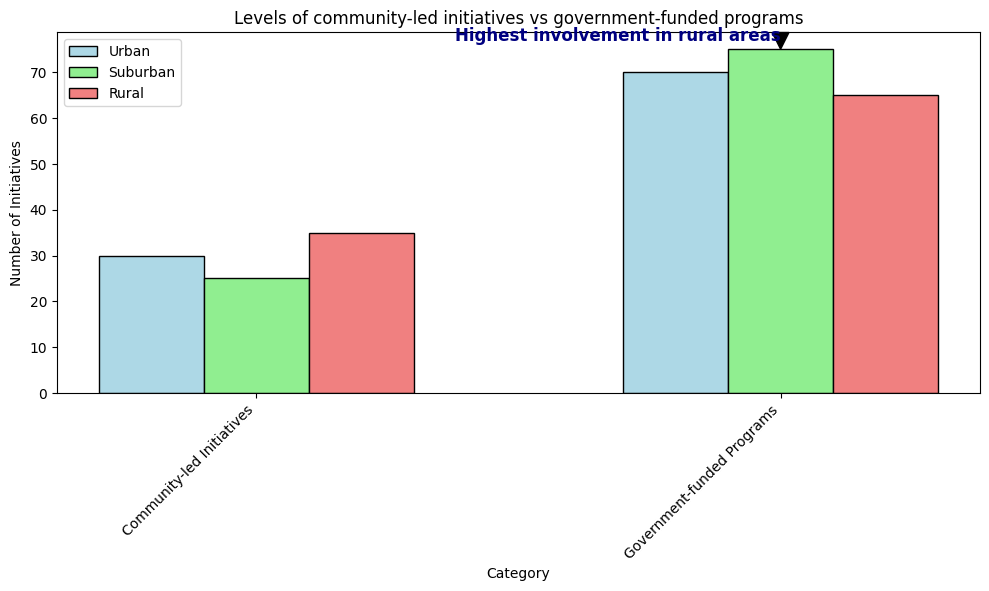What is the total number of Community-led Initiatives across all areas? To find the total number of Community-led Initiatives, sum the values for Urban (30), Suburban (25), and Rural (35). The calculation is 30 + 25 + 35.
Answer: 90 Which has a greater number of Government-funded Programs, Urban or Rural areas? Compare the bar heights for Urban (70) and Rural (65) in the Government-funded Programs category.
Answer: Urban What is the difference between the number of Suburban and Rural Community-led Initiatives? Subtract the value for Rural (35) from the value for Suburban (25) in the Community-led Initiatives category, so 35 - 25.
Answer: 10 Do Government-funded Programs or Community-led Initiatives have higher involvement in Rural areas? Compare the bar heights for Rural areas in both categories: Government-funded Programs (65) and Community-led Initiatives (35).
Answer: Government-funded Programs What is the average number of Government-funded Programs across the three areas? To find the average, sum the values for Government-funded Programs in Urban (70), Suburban (75), and Rural (65), then divide by 3. The calculation is (70 + 75 + 65) / 3.
Answer: 70 Which area has the highest number of Community-led Initiatives? Compare the bar heights for Community-led Initiatives in Urban (30), Suburban (25), and Rural (35).
Answer: Rural By how much do Government-funded Programs in Suburban areas exceed those in Urban areas? Subtract the value for Urban (70) from the value for Suburban (75) in the Government-funded Programs category, so 75 - 70.
Answer: 5 Which category has a greater total number of initiatives across all areas, Community-led Initiatives or Government-funded Programs? Sum the values for each category across all areas: Community-led Initiatives (30 + 25 + 35) and Government-funded Programs (70 + 75 + 65) and compare.
Answer: Government-funded Programs What visual element indicates the highest involvement in Rural areas according to the text annotation? Look at the annotation in the figure, which points to the bar related to Community-led Initiatives in Rural areas and mentions "Highest involvement in rural areas."
Answer: Text annotation How many more Government-funded Programs than Community-led Initiatives are there in Urban areas? Subtract the value for Community-led Initiatives (30) from the value for Government-funded Programs (70) in Urban areas, so 70 - 30.
Answer: 40 